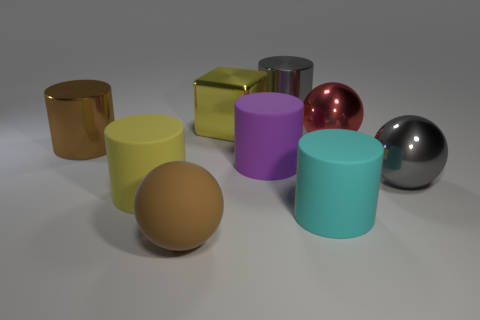Subtract all shiny balls. How many balls are left? 1 Subtract all purple cylinders. How many cylinders are left? 4 Subtract 2 cylinders. How many cylinders are left? 3 Subtract all purple cylinders. Subtract all gray blocks. How many cylinders are left? 4 Subtract all spheres. How many objects are left? 6 Subtract all large cyan things. Subtract all large shiny cubes. How many objects are left? 7 Add 5 rubber balls. How many rubber balls are left? 6 Add 2 tiny cyan rubber cubes. How many tiny cyan rubber cubes exist? 2 Subtract 1 gray cylinders. How many objects are left? 8 